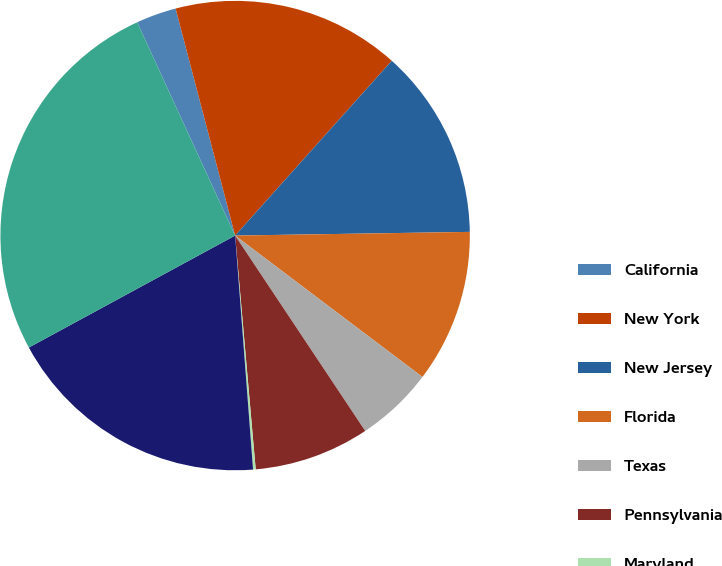Convert chart to OTSL. <chart><loc_0><loc_0><loc_500><loc_500><pie_chart><fcel>California<fcel>New York<fcel>New Jersey<fcel>Florida<fcel>Texas<fcel>Pennsylvania<fcel>Maryland<fcel>Other states<fcel>Total^<nl><fcel>2.77%<fcel>15.71%<fcel>13.12%<fcel>10.54%<fcel>5.36%<fcel>7.95%<fcel>0.18%<fcel>18.3%<fcel>26.06%<nl></chart> 